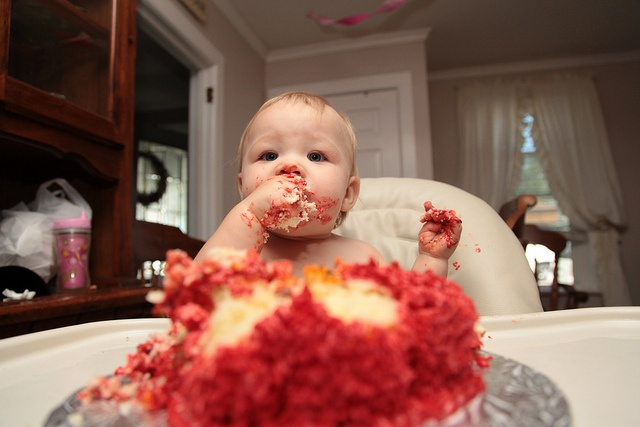Describe the objects in this image and their specific colors. I can see dining table in maroon, brown, tan, and lightgray tones, cake in maroon, brown, salmon, and tan tones, people in maroon, tan, brown, and salmon tones, chair in maroon, tan, and beige tones, and chair in maroon, black, white, and gray tones in this image. 